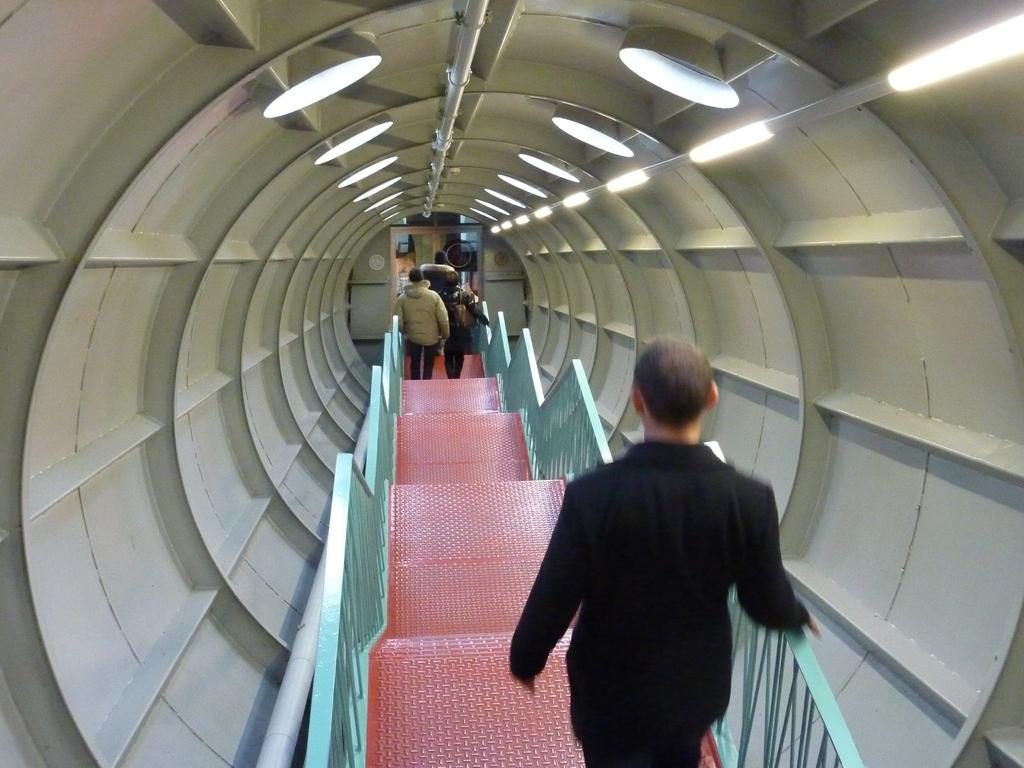How many people are in the image? There is a group of people in the image. Where are the people standing in the image? The people are standing on a staircase. What feature does the staircase have? The staircase has a railing. What is the location of the staircase in the image? The staircase is inside a tunnel. What can be seen in the background of the image? There are lights and doors in the background of the image. What type of crack is visible on the mother's face in the image? There is no mother or crack present in the image. 